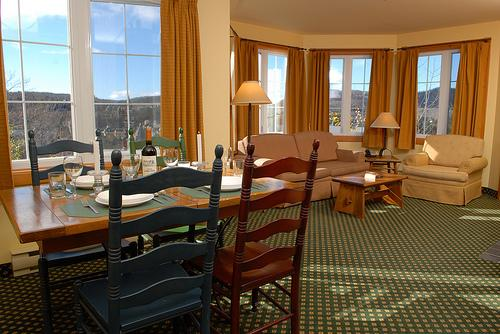In a single sentence, describe the elements visible through the window. There are mountains in the background, sunlight on the floor, and three windows in a row revealing a beautiful outdoor view. Talk about the carpet pattern, color, and surrounding area. There's a pattern on the carpet featuring tan diamonds on a darker background, positioned near a wooden coffee table and illuminated by sunlight from the window. Describe the seating arrangement and color variation of chairs around the table. There are four chairs at the table including a blue chair, a red chair, a green chair, and a green painted wooden dining chair. Two other chairs are sitting beside the table. Express the setting and ambience of the image in a creative and descriptive manner. A cozy domestic scene unfolds with warm sunlight filtering through the windows, casting a glow on the meticulously set table, inviting chairs, and comfortable family room area. Write briefly about the curtains and windows present in the image. Long yellow curtains are draped alongside a window with a glass pane that brings in light, and white-painted wooden muntin bars divide the panes. Compose a few sentences detailing the appearance and contents of the dining table. The dining table is set with white plates, green placemats, and forks. A lit candle, glass, and a wine bottle with red seal are present. A green wine bottle and burgundy wine glass are also visible. Mention the key features of the setting in the image using simple sentences. There is a domestic setting with a table set for mealtime. There are chairs, curtains, and mountains visible through the window. There's also a family room area with couches and lamps. Briefly mention the objects and furniture found in the family room area. The family room area has a relaxing chair, an upholstered love seat, wooden coffee table, tall lamp, and a wooden end table with a lamp on it. Lamps beside the couches are also seen. Describe the table setting focusing on the variety of food and beverage utensils. The table is adorned with dinner forks on green placemats next to white plates, a lit white candle, and wine bottles, while burgundy wine glasses stand ready to be filled. Summarize the essential furnishings and positionings of the family room. In the family room, an upholstered recliner chair faces a couch, and there are lamp shades, a wooden coffee table without storage, and a patterned carpet with tan diamonds underneath. 